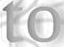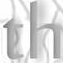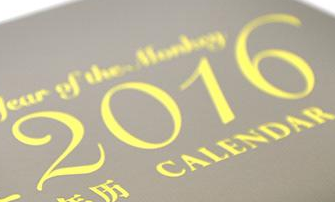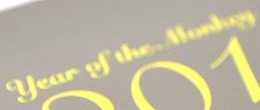Read the text content from these images in order, separated by a semicolon. to; th; 2016; # 